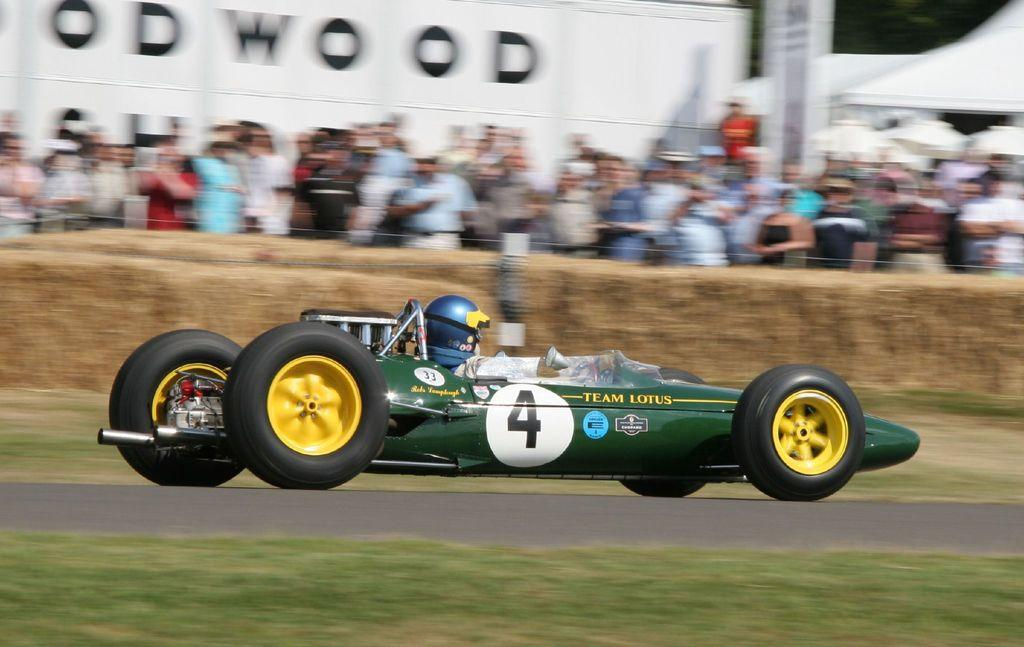What type of vehicle is in the image? There is a speed car in the image. Who is operating the speed car? A person is riding the speed car. How many geese are walking in the image? There are no geese present in the image. What type of rest is the person taking while riding the speed car? The person is actively riding the speed car and not taking any rest in the image. 